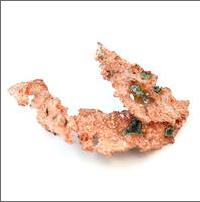How can the physical properties of native copper seen in the image be used in practical applications? Native copper's physical properties, such as its excellent conductivity of electricity and heat, combined with its ductility and malleability, make it ideal for use in electrical wiring and electronic products. The copper's natural occurrence, as seen in the image, often highlights the minimal processing needed to utilize it in various applications, emphasizing its practical value in industrial and technological fields. 